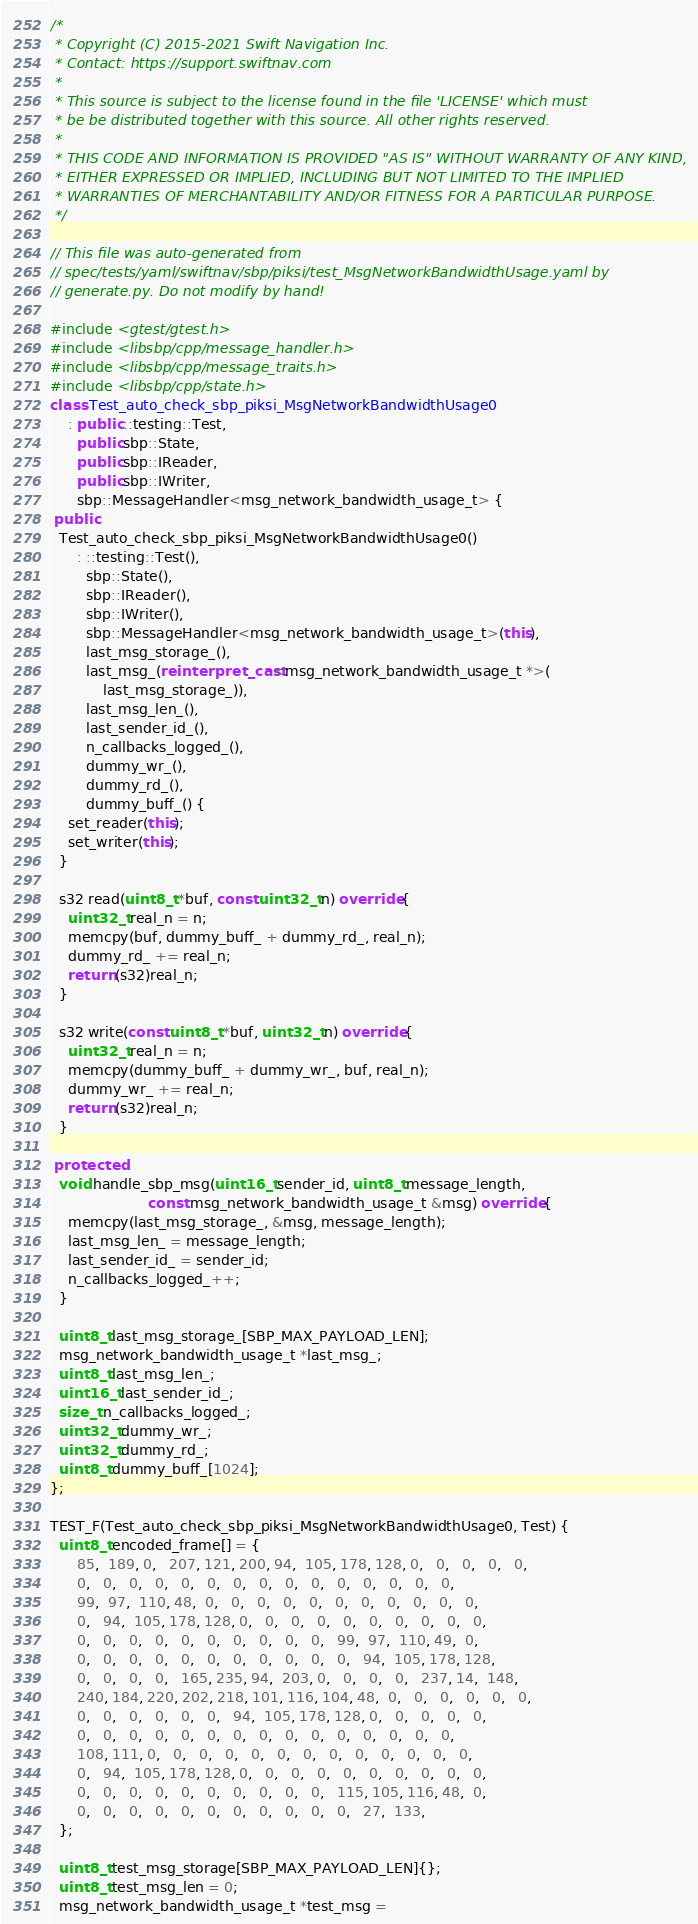Convert code to text. <code><loc_0><loc_0><loc_500><loc_500><_C++_>/*
 * Copyright (C) 2015-2021 Swift Navigation Inc.
 * Contact: https://support.swiftnav.com
 *
 * This source is subject to the license found in the file 'LICENSE' which must
 * be be distributed together with this source. All other rights reserved.
 *
 * THIS CODE AND INFORMATION IS PROVIDED "AS IS" WITHOUT WARRANTY OF ANY KIND,
 * EITHER EXPRESSED OR IMPLIED, INCLUDING BUT NOT LIMITED TO THE IMPLIED
 * WARRANTIES OF MERCHANTABILITY AND/OR FITNESS FOR A PARTICULAR PURPOSE.
 */

// This file was auto-generated from
// spec/tests/yaml/swiftnav/sbp/piksi/test_MsgNetworkBandwidthUsage.yaml by
// generate.py. Do not modify by hand!

#include <gtest/gtest.h>
#include <libsbp/cpp/message_handler.h>
#include <libsbp/cpp/message_traits.h>
#include <libsbp/cpp/state.h>
class Test_auto_check_sbp_piksi_MsgNetworkBandwidthUsage0
    : public ::testing::Test,
      public sbp::State,
      public sbp::IReader,
      public sbp::IWriter,
      sbp::MessageHandler<msg_network_bandwidth_usage_t> {
 public:
  Test_auto_check_sbp_piksi_MsgNetworkBandwidthUsage0()
      : ::testing::Test(),
        sbp::State(),
        sbp::IReader(),
        sbp::IWriter(),
        sbp::MessageHandler<msg_network_bandwidth_usage_t>(this),
        last_msg_storage_(),
        last_msg_(reinterpret_cast<msg_network_bandwidth_usage_t *>(
            last_msg_storage_)),
        last_msg_len_(),
        last_sender_id_(),
        n_callbacks_logged_(),
        dummy_wr_(),
        dummy_rd_(),
        dummy_buff_() {
    set_reader(this);
    set_writer(this);
  }

  s32 read(uint8_t *buf, const uint32_t n) override {
    uint32_t real_n = n;
    memcpy(buf, dummy_buff_ + dummy_rd_, real_n);
    dummy_rd_ += real_n;
    return (s32)real_n;
  }

  s32 write(const uint8_t *buf, uint32_t n) override {
    uint32_t real_n = n;
    memcpy(dummy_buff_ + dummy_wr_, buf, real_n);
    dummy_wr_ += real_n;
    return (s32)real_n;
  }

 protected:
  void handle_sbp_msg(uint16_t sender_id, uint8_t message_length,
                      const msg_network_bandwidth_usage_t &msg) override {
    memcpy(last_msg_storage_, &msg, message_length);
    last_msg_len_ = message_length;
    last_sender_id_ = sender_id;
    n_callbacks_logged_++;
  }

  uint8_t last_msg_storage_[SBP_MAX_PAYLOAD_LEN];
  msg_network_bandwidth_usage_t *last_msg_;
  uint8_t last_msg_len_;
  uint16_t last_sender_id_;
  size_t n_callbacks_logged_;
  uint32_t dummy_wr_;
  uint32_t dummy_rd_;
  uint8_t dummy_buff_[1024];
};

TEST_F(Test_auto_check_sbp_piksi_MsgNetworkBandwidthUsage0, Test) {
  uint8_t encoded_frame[] = {
      85,  189, 0,   207, 121, 200, 94,  105, 178, 128, 0,   0,   0,   0,   0,
      0,   0,   0,   0,   0,   0,   0,   0,   0,   0,   0,   0,   0,   0,   0,
      99,  97,  110, 48,  0,   0,   0,   0,   0,   0,   0,   0,   0,   0,   0,
      0,   94,  105, 178, 128, 0,   0,   0,   0,   0,   0,   0,   0,   0,   0,
      0,   0,   0,   0,   0,   0,   0,   0,   0,   0,   99,  97,  110, 49,  0,
      0,   0,   0,   0,   0,   0,   0,   0,   0,   0,   0,   94,  105, 178, 128,
      0,   0,   0,   0,   165, 235, 94,  203, 0,   0,   0,   0,   237, 14,  148,
      240, 184, 220, 202, 218, 101, 116, 104, 48,  0,   0,   0,   0,   0,   0,
      0,   0,   0,   0,   0,   0,   94,  105, 178, 128, 0,   0,   0,   0,   0,
      0,   0,   0,   0,   0,   0,   0,   0,   0,   0,   0,   0,   0,   0,   0,
      108, 111, 0,   0,   0,   0,   0,   0,   0,   0,   0,   0,   0,   0,   0,
      0,   94,  105, 178, 128, 0,   0,   0,   0,   0,   0,   0,   0,   0,   0,
      0,   0,   0,   0,   0,   0,   0,   0,   0,   0,   115, 105, 116, 48,  0,
      0,   0,   0,   0,   0,   0,   0,   0,   0,   0,   0,   27,  133,
  };

  uint8_t test_msg_storage[SBP_MAX_PAYLOAD_LEN]{};
  uint8_t test_msg_len = 0;
  msg_network_bandwidth_usage_t *test_msg =</code> 